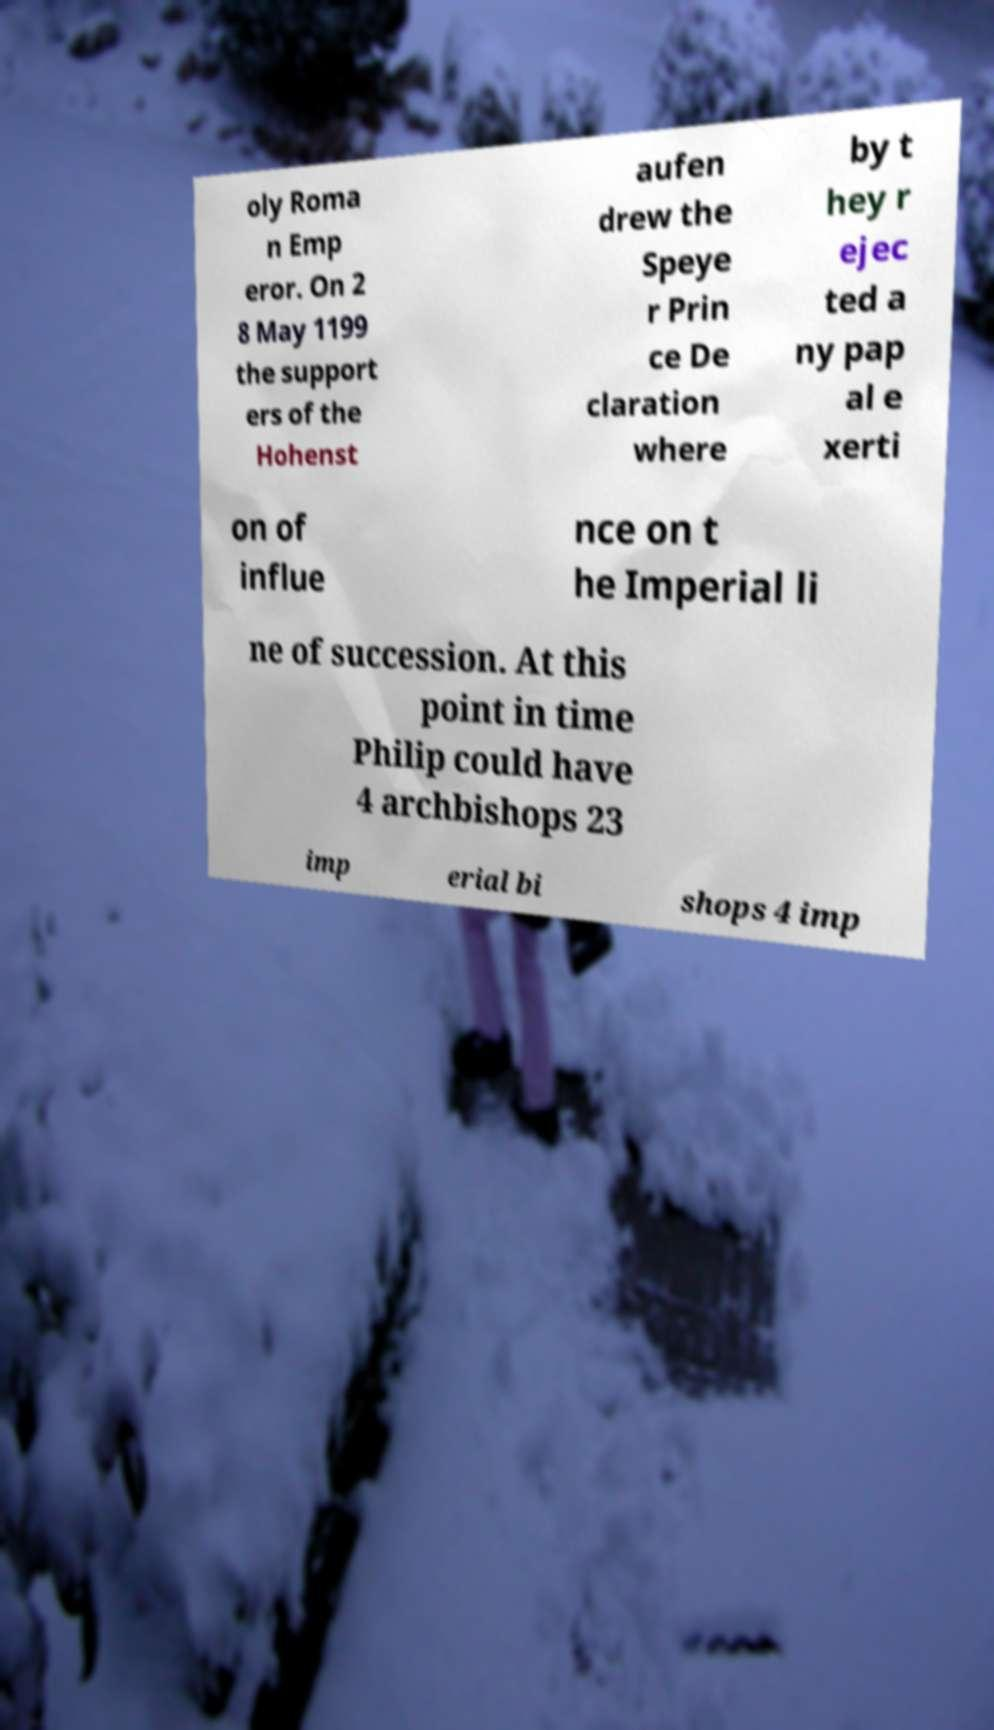Can you read and provide the text displayed in the image?This photo seems to have some interesting text. Can you extract and type it out for me? oly Roma n Emp eror. On 2 8 May 1199 the support ers of the Hohenst aufen drew the Speye r Prin ce De claration where by t hey r ejec ted a ny pap al e xerti on of influe nce on t he Imperial li ne of succession. At this point in time Philip could have 4 archbishops 23 imp erial bi shops 4 imp 